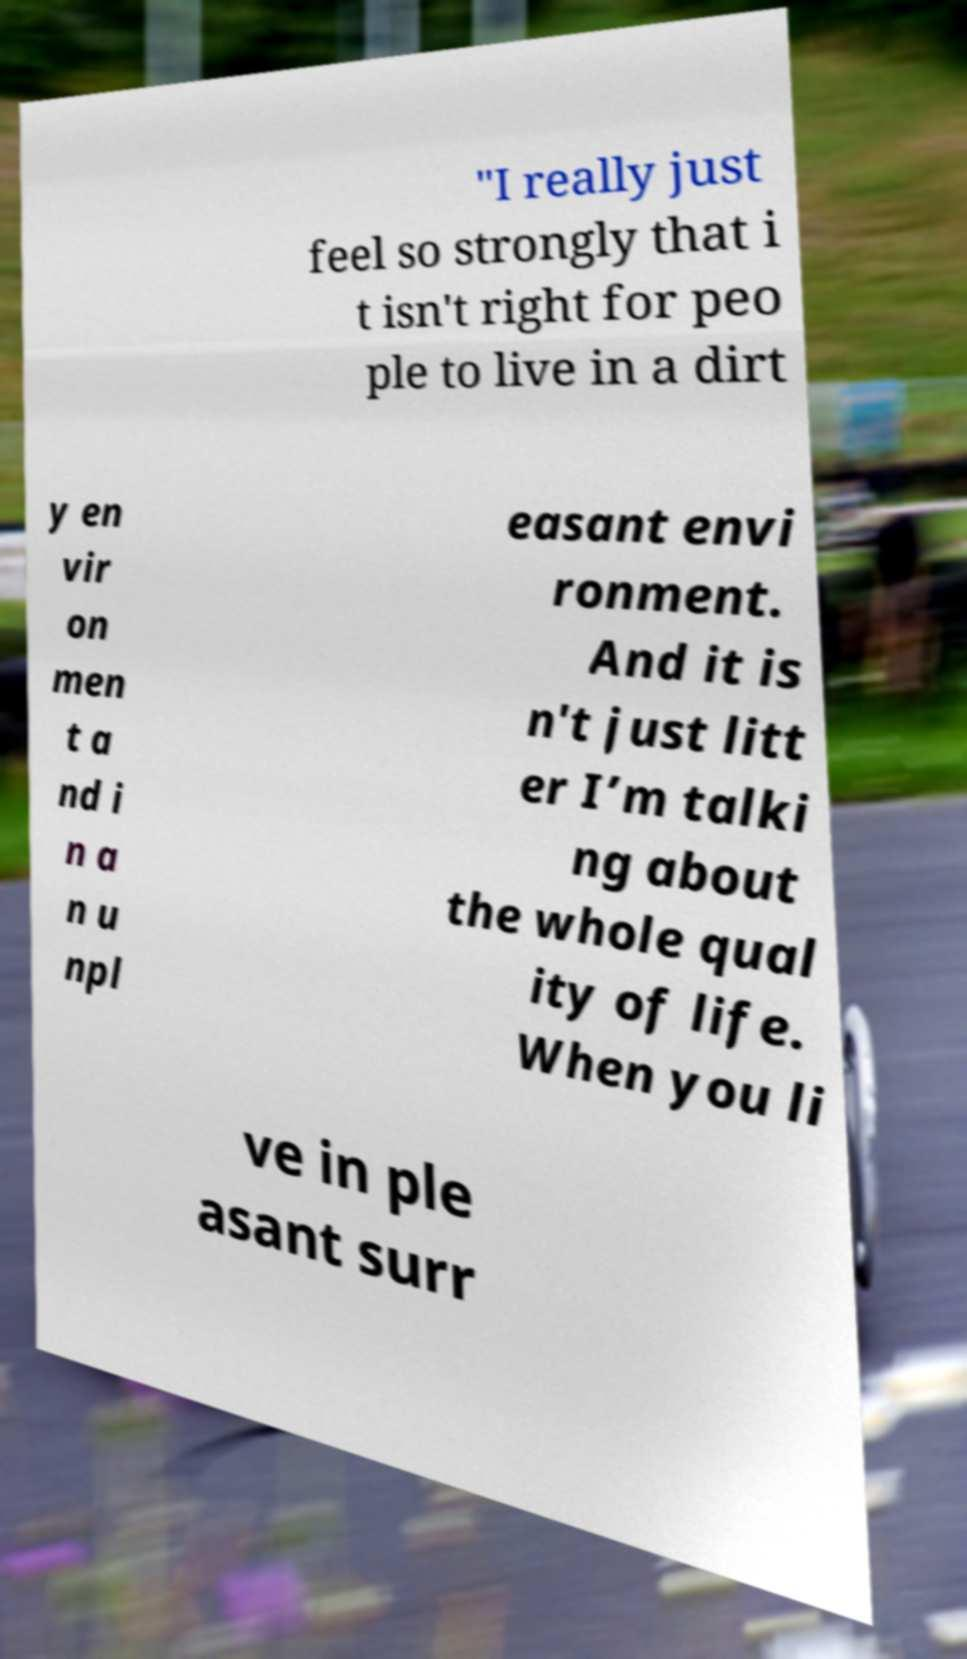For documentation purposes, I need the text within this image transcribed. Could you provide that? "I really just feel so strongly that i t isn't right for peo ple to live in a dirt y en vir on men t a nd i n a n u npl easant envi ronment. And it is n't just litt er I’m talki ng about the whole qual ity of life. When you li ve in ple asant surr 